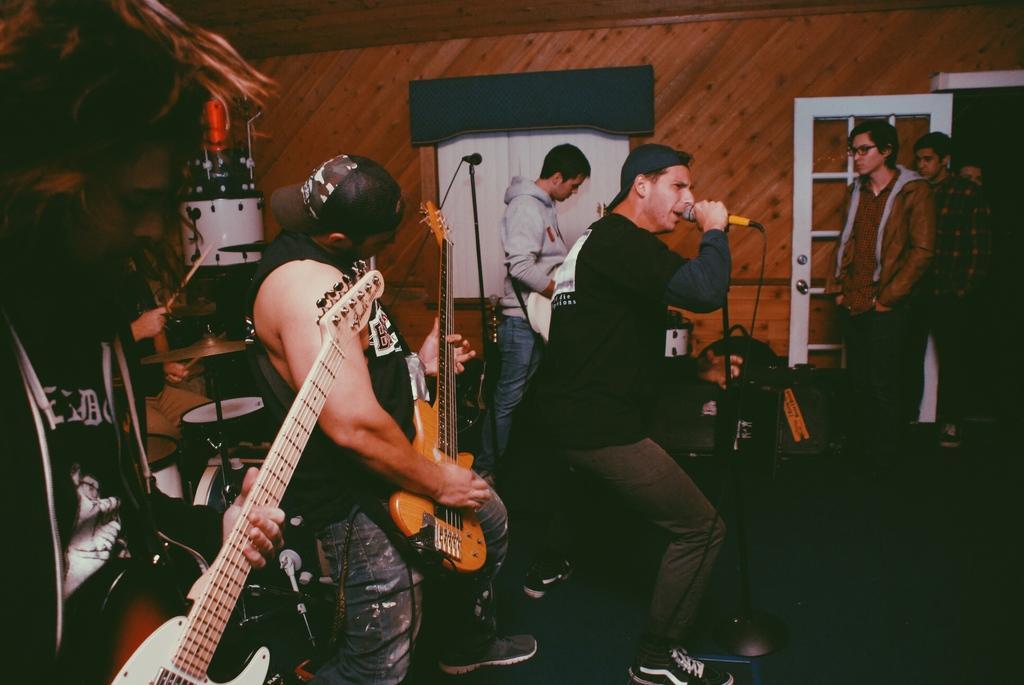Please provide a concise description of this image. In this picture a group of people standing on the right, people holding a microphone here and these people are playing the guitar 